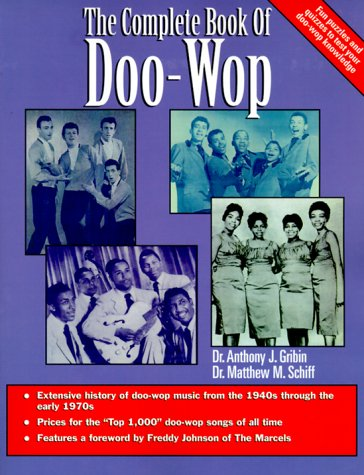Can you explain the significance of the artists depicted on the cover of this book? The artists on the cover are iconic figures in the Doo-Wop music scene, representing the era’s influential styles and sounds that the book discusses in detail. 